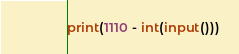Convert code to text. <code><loc_0><loc_0><loc_500><loc_500><_Python_>print(1110 - int(input()))</code> 